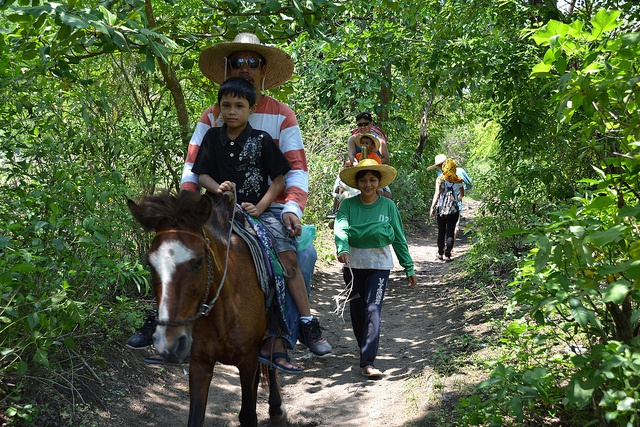Describe the objects in this image and their specific colors. I can see horse in teal, black, gray, and darkgray tones, people in teal, black, gray, and maroon tones, people in teal, black, maroon, brown, and gray tones, people in teal, black, gray, and darkgreen tones, and people in teal, black, gray, white, and darkgray tones in this image. 